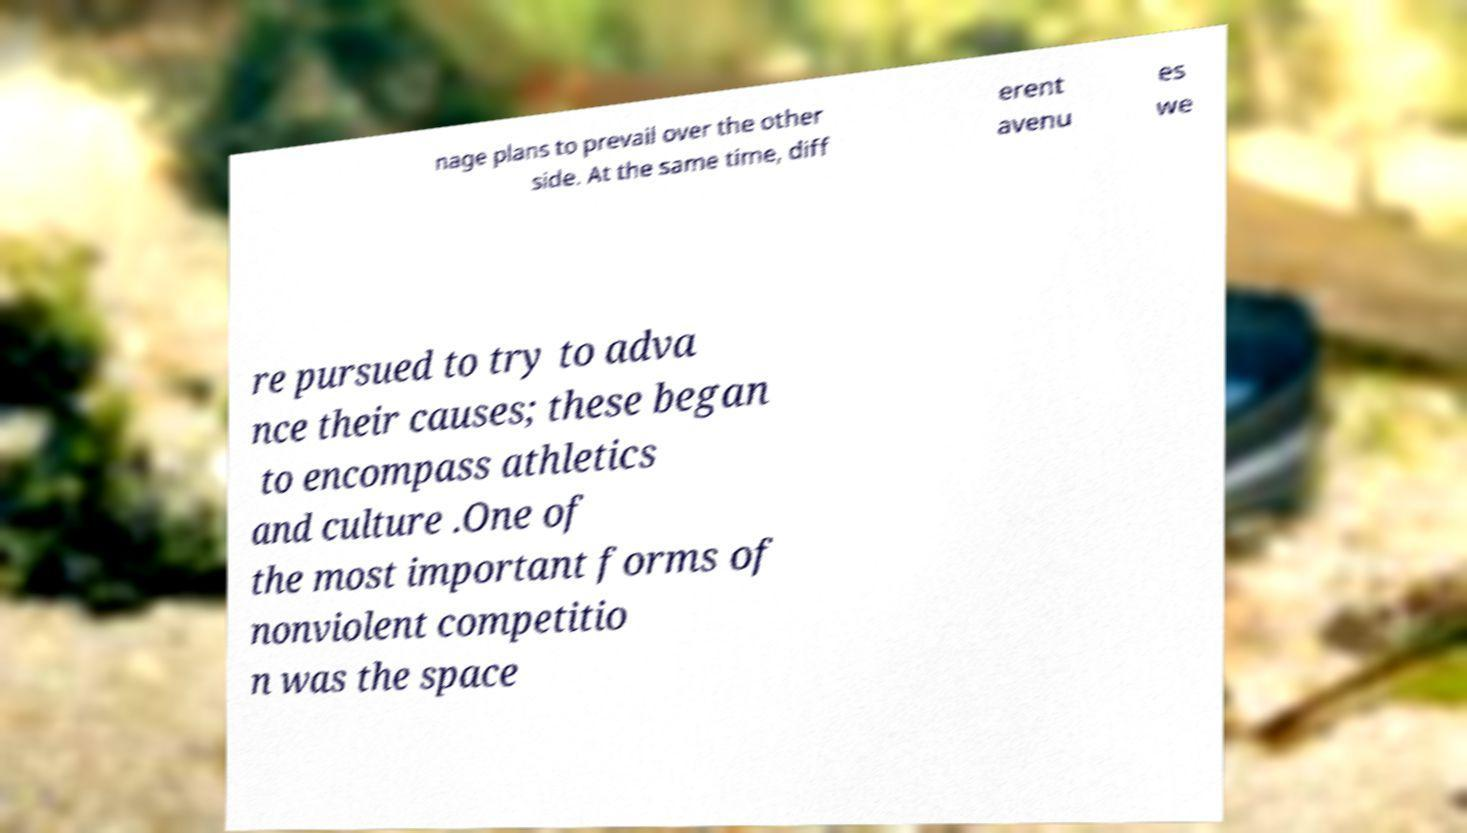What messages or text are displayed in this image? I need them in a readable, typed format. nage plans to prevail over the other side. At the same time, diff erent avenu es we re pursued to try to adva nce their causes; these began to encompass athletics and culture .One of the most important forms of nonviolent competitio n was the space 